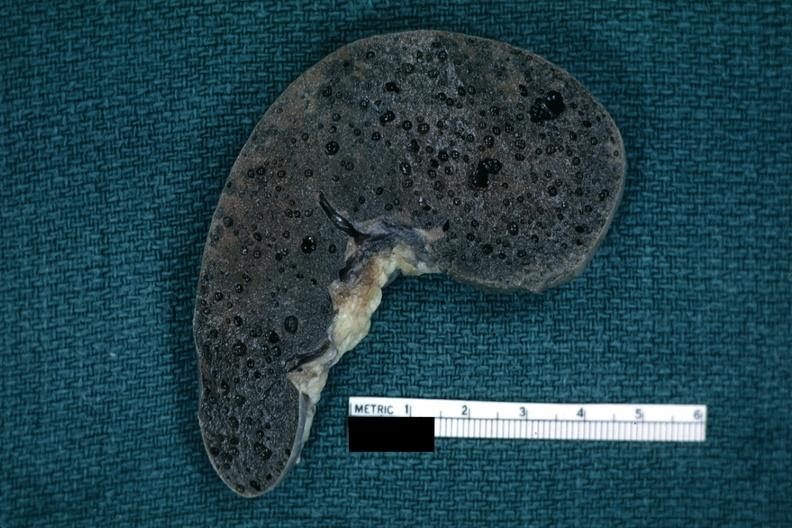s spleen present?
Answer the question using a single word or phrase. Yes 